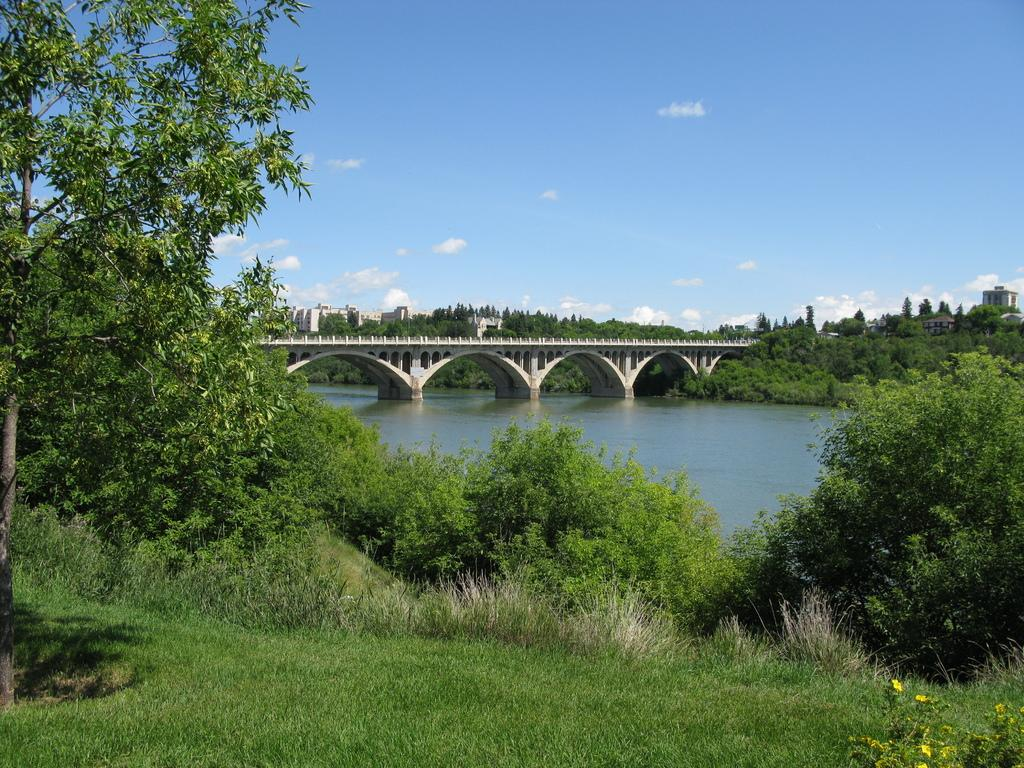What structure is present in the image that allows people or vehicles to cross over water? There is a bridge in the image that allows people or vehicles to cross over water. What is the bridge situated above in the image? The bridge is above water in the image. What type of vegetation can be seen in the image? There are trees in the image. What type of man-made structures can be seen in the image? There are buildings in the image. What type of ground cover is present in the image? There is grass in the image. What can be seen in the background of the image? The sky is visible in the background of the image. What is the condition of the sky in the image? There are clouds in the sky in the image. What year is the division between the two countries taking place in the image? There is no indication of a division between two countries or any specific year in the image. 